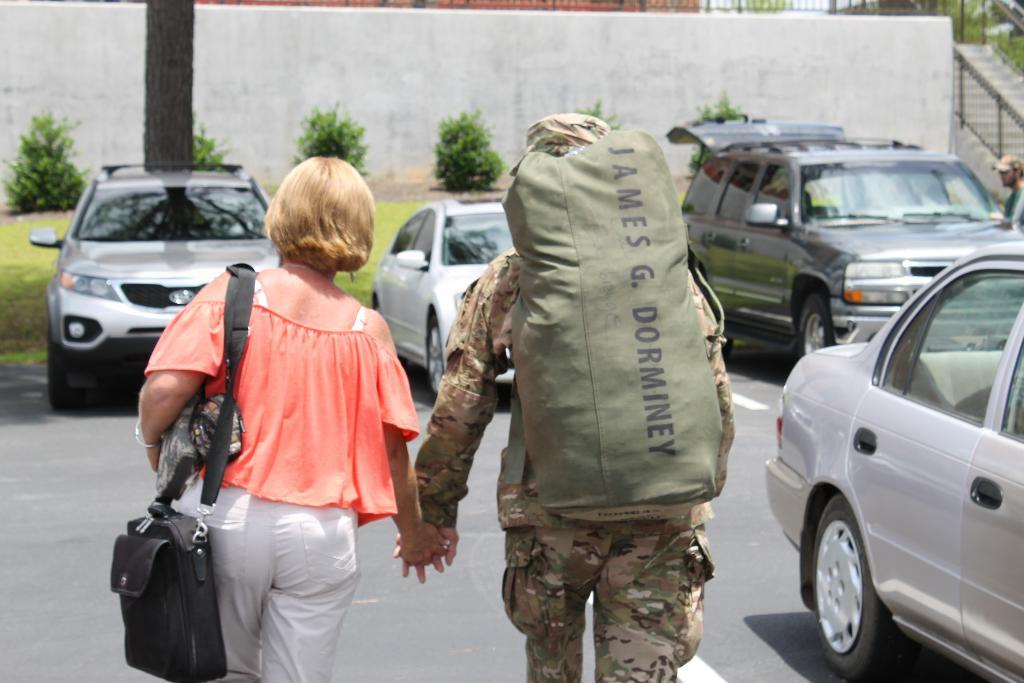How many people are in the image? There are two persons in the image. What are the two persons doing? The two persons are walking and holding hands. What are the two persons wearing? The two persons are wearing bags. What can be seen on the road in the image? There are vehicles on the road in the image. What is visible in the background of the image? There is a wall, a fence, plants, and grass in the background of the image. What type of clover can be seen growing on the wall in the image? There is no clover visible in the image, and the wall is not described as having any vegetation growing on it. 